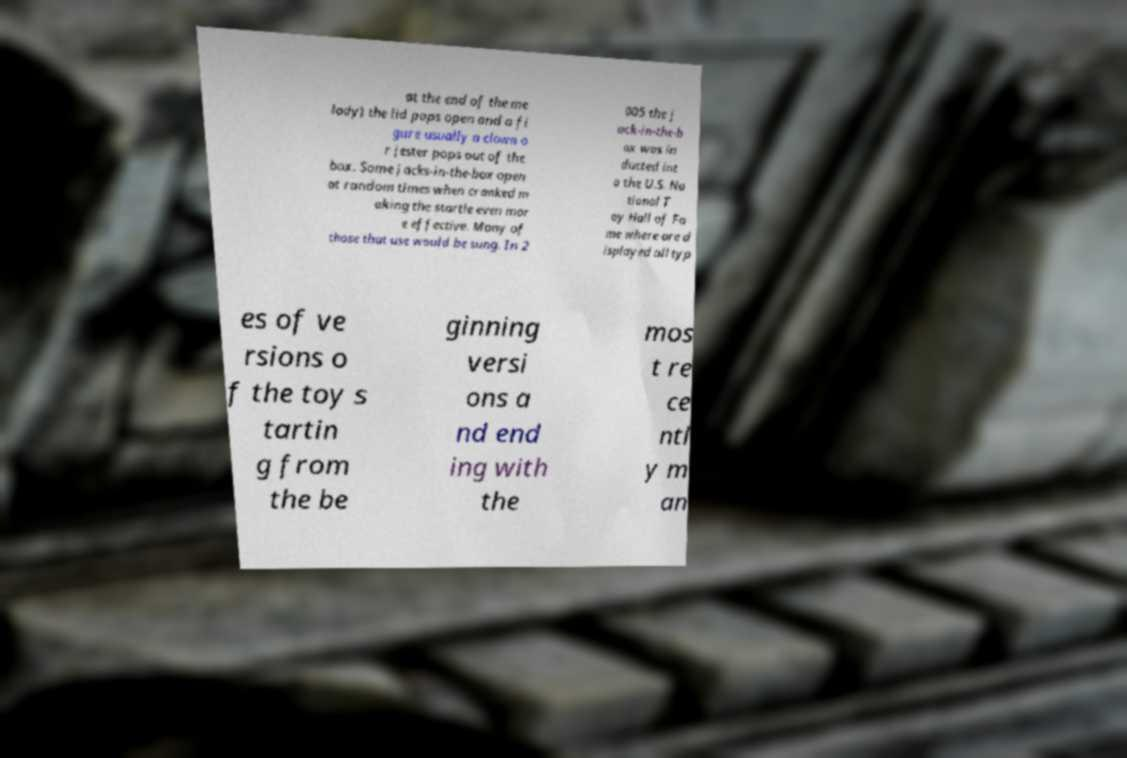Please identify and transcribe the text found in this image. at the end of the me lody) the lid pops open and a fi gure usually a clown o r jester pops out of the box. Some jacks-in-the-box open at random times when cranked m aking the startle even mor e effective. Many of those that use would be sung. In 2 005 the j ack-in-the-b ox was in ducted int o the U.S. Na tional T oy Hall of Fa me where are d isplayed all typ es of ve rsions o f the toy s tartin g from the be ginning versi ons a nd end ing with the mos t re ce ntl y m an 